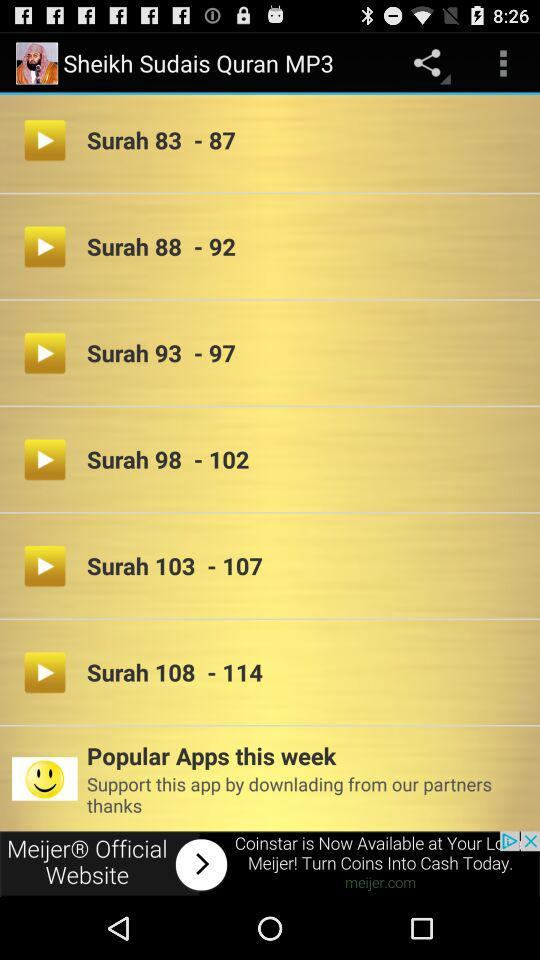What is the application name? The application name is "Sheikh Sudais Quran MP3". 